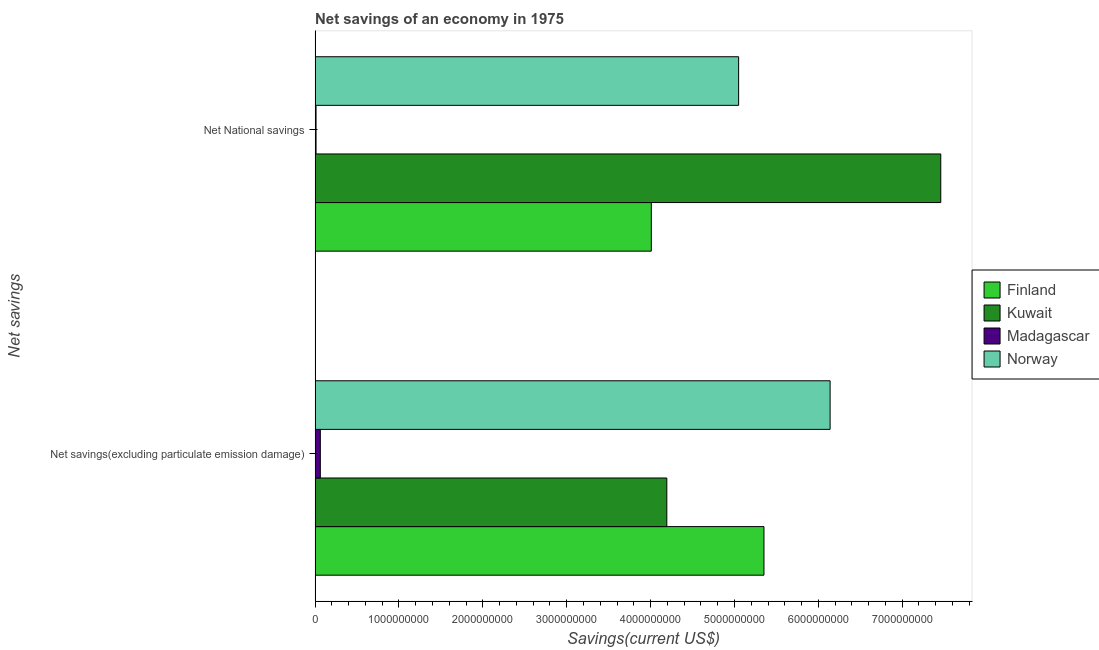How many different coloured bars are there?
Give a very brief answer. 4. Are the number of bars on each tick of the Y-axis equal?
Offer a very short reply. Yes. How many bars are there on the 2nd tick from the bottom?
Give a very brief answer. 4. What is the label of the 2nd group of bars from the top?
Provide a succinct answer. Net savings(excluding particulate emission damage). What is the net savings(excluding particulate emission damage) in Kuwait?
Ensure brevity in your answer.  4.19e+09. Across all countries, what is the maximum net savings(excluding particulate emission damage)?
Provide a short and direct response. 6.14e+09. Across all countries, what is the minimum net savings(excluding particulate emission damage)?
Make the answer very short. 6.24e+07. In which country was the net national savings maximum?
Offer a terse response. Kuwait. In which country was the net savings(excluding particulate emission damage) minimum?
Your answer should be very brief. Madagascar. What is the total net savings(excluding particulate emission damage) in the graph?
Give a very brief answer. 1.57e+1. What is the difference between the net savings(excluding particulate emission damage) in Norway and that in Finland?
Provide a succinct answer. 7.89e+08. What is the difference between the net savings(excluding particulate emission damage) in Kuwait and the net national savings in Madagascar?
Offer a very short reply. 4.18e+09. What is the average net savings(excluding particulate emission damage) per country?
Offer a very short reply. 3.94e+09. What is the difference between the net national savings and net savings(excluding particulate emission damage) in Madagascar?
Offer a terse response. -5.12e+07. What is the ratio of the net national savings in Finland to that in Madagascar?
Your answer should be very brief. 357.63. In how many countries, is the net savings(excluding particulate emission damage) greater than the average net savings(excluding particulate emission damage) taken over all countries?
Ensure brevity in your answer.  3. What does the 4th bar from the bottom in Net savings(excluding particulate emission damage) represents?
Your answer should be compact. Norway. Are all the bars in the graph horizontal?
Your answer should be compact. Yes. How many countries are there in the graph?
Give a very brief answer. 4. Are the values on the major ticks of X-axis written in scientific E-notation?
Your answer should be very brief. No. Does the graph contain any zero values?
Provide a succinct answer. No. Does the graph contain grids?
Keep it short and to the point. No. How many legend labels are there?
Your response must be concise. 4. What is the title of the graph?
Ensure brevity in your answer.  Net savings of an economy in 1975. What is the label or title of the X-axis?
Give a very brief answer. Savings(current US$). What is the label or title of the Y-axis?
Provide a short and direct response. Net savings. What is the Savings(current US$) in Finland in Net savings(excluding particulate emission damage)?
Your response must be concise. 5.35e+09. What is the Savings(current US$) in Kuwait in Net savings(excluding particulate emission damage)?
Keep it short and to the point. 4.19e+09. What is the Savings(current US$) of Madagascar in Net savings(excluding particulate emission damage)?
Your answer should be very brief. 6.24e+07. What is the Savings(current US$) in Norway in Net savings(excluding particulate emission damage)?
Keep it short and to the point. 6.14e+09. What is the Savings(current US$) of Finland in Net National savings?
Make the answer very short. 4.01e+09. What is the Savings(current US$) in Kuwait in Net National savings?
Provide a succinct answer. 7.46e+09. What is the Savings(current US$) of Madagascar in Net National savings?
Ensure brevity in your answer.  1.12e+07. What is the Savings(current US$) in Norway in Net National savings?
Keep it short and to the point. 5.05e+09. Across all Net savings, what is the maximum Savings(current US$) in Finland?
Keep it short and to the point. 5.35e+09. Across all Net savings, what is the maximum Savings(current US$) of Kuwait?
Provide a succinct answer. 7.46e+09. Across all Net savings, what is the maximum Savings(current US$) in Madagascar?
Provide a short and direct response. 6.24e+07. Across all Net savings, what is the maximum Savings(current US$) of Norway?
Give a very brief answer. 6.14e+09. Across all Net savings, what is the minimum Savings(current US$) of Finland?
Your response must be concise. 4.01e+09. Across all Net savings, what is the minimum Savings(current US$) in Kuwait?
Provide a succinct answer. 4.19e+09. Across all Net savings, what is the minimum Savings(current US$) in Madagascar?
Keep it short and to the point. 1.12e+07. Across all Net savings, what is the minimum Savings(current US$) of Norway?
Give a very brief answer. 5.05e+09. What is the total Savings(current US$) of Finland in the graph?
Ensure brevity in your answer.  9.36e+09. What is the total Savings(current US$) of Kuwait in the graph?
Your answer should be compact. 1.17e+1. What is the total Savings(current US$) in Madagascar in the graph?
Your answer should be compact. 7.36e+07. What is the total Savings(current US$) of Norway in the graph?
Offer a very short reply. 1.12e+1. What is the difference between the Savings(current US$) of Finland in Net savings(excluding particulate emission damage) and that in Net National savings?
Offer a terse response. 1.34e+09. What is the difference between the Savings(current US$) of Kuwait in Net savings(excluding particulate emission damage) and that in Net National savings?
Provide a succinct answer. -3.27e+09. What is the difference between the Savings(current US$) in Madagascar in Net savings(excluding particulate emission damage) and that in Net National savings?
Give a very brief answer. 5.12e+07. What is the difference between the Savings(current US$) of Norway in Net savings(excluding particulate emission damage) and that in Net National savings?
Offer a terse response. 1.09e+09. What is the difference between the Savings(current US$) in Finland in Net savings(excluding particulate emission damage) and the Savings(current US$) in Kuwait in Net National savings?
Give a very brief answer. -2.11e+09. What is the difference between the Savings(current US$) in Finland in Net savings(excluding particulate emission damage) and the Savings(current US$) in Madagascar in Net National savings?
Offer a very short reply. 5.34e+09. What is the difference between the Savings(current US$) in Finland in Net savings(excluding particulate emission damage) and the Savings(current US$) in Norway in Net National savings?
Keep it short and to the point. 3.02e+08. What is the difference between the Savings(current US$) in Kuwait in Net savings(excluding particulate emission damage) and the Savings(current US$) in Madagascar in Net National savings?
Ensure brevity in your answer.  4.18e+09. What is the difference between the Savings(current US$) of Kuwait in Net savings(excluding particulate emission damage) and the Savings(current US$) of Norway in Net National savings?
Provide a short and direct response. -8.56e+08. What is the difference between the Savings(current US$) in Madagascar in Net savings(excluding particulate emission damage) and the Savings(current US$) in Norway in Net National savings?
Keep it short and to the point. -4.99e+09. What is the average Savings(current US$) in Finland per Net savings?
Provide a succinct answer. 4.68e+09. What is the average Savings(current US$) of Kuwait per Net savings?
Provide a short and direct response. 5.83e+09. What is the average Savings(current US$) of Madagascar per Net savings?
Ensure brevity in your answer.  3.68e+07. What is the average Savings(current US$) of Norway per Net savings?
Make the answer very short. 5.60e+09. What is the difference between the Savings(current US$) in Finland and Savings(current US$) in Kuwait in Net savings(excluding particulate emission damage)?
Provide a short and direct response. 1.16e+09. What is the difference between the Savings(current US$) in Finland and Savings(current US$) in Madagascar in Net savings(excluding particulate emission damage)?
Offer a terse response. 5.29e+09. What is the difference between the Savings(current US$) of Finland and Savings(current US$) of Norway in Net savings(excluding particulate emission damage)?
Make the answer very short. -7.89e+08. What is the difference between the Savings(current US$) of Kuwait and Savings(current US$) of Madagascar in Net savings(excluding particulate emission damage)?
Ensure brevity in your answer.  4.13e+09. What is the difference between the Savings(current US$) in Kuwait and Savings(current US$) in Norway in Net savings(excluding particulate emission damage)?
Your response must be concise. -1.95e+09. What is the difference between the Savings(current US$) of Madagascar and Savings(current US$) of Norway in Net savings(excluding particulate emission damage)?
Offer a very short reply. -6.08e+09. What is the difference between the Savings(current US$) of Finland and Savings(current US$) of Kuwait in Net National savings?
Your response must be concise. -3.45e+09. What is the difference between the Savings(current US$) in Finland and Savings(current US$) in Madagascar in Net National savings?
Give a very brief answer. 4.00e+09. What is the difference between the Savings(current US$) of Finland and Savings(current US$) of Norway in Net National savings?
Your answer should be very brief. -1.04e+09. What is the difference between the Savings(current US$) of Kuwait and Savings(current US$) of Madagascar in Net National savings?
Give a very brief answer. 7.45e+09. What is the difference between the Savings(current US$) of Kuwait and Savings(current US$) of Norway in Net National savings?
Your answer should be compact. 2.41e+09. What is the difference between the Savings(current US$) in Madagascar and Savings(current US$) in Norway in Net National savings?
Offer a very short reply. -5.04e+09. What is the ratio of the Savings(current US$) of Finland in Net savings(excluding particulate emission damage) to that in Net National savings?
Your answer should be compact. 1.34. What is the ratio of the Savings(current US$) in Kuwait in Net savings(excluding particulate emission damage) to that in Net National savings?
Provide a succinct answer. 0.56. What is the ratio of the Savings(current US$) of Madagascar in Net savings(excluding particulate emission damage) to that in Net National savings?
Offer a terse response. 5.57. What is the ratio of the Savings(current US$) of Norway in Net savings(excluding particulate emission damage) to that in Net National savings?
Your answer should be compact. 1.22. What is the difference between the highest and the second highest Savings(current US$) in Finland?
Ensure brevity in your answer.  1.34e+09. What is the difference between the highest and the second highest Savings(current US$) in Kuwait?
Your answer should be compact. 3.27e+09. What is the difference between the highest and the second highest Savings(current US$) of Madagascar?
Keep it short and to the point. 5.12e+07. What is the difference between the highest and the second highest Savings(current US$) of Norway?
Keep it short and to the point. 1.09e+09. What is the difference between the highest and the lowest Savings(current US$) in Finland?
Provide a short and direct response. 1.34e+09. What is the difference between the highest and the lowest Savings(current US$) of Kuwait?
Give a very brief answer. 3.27e+09. What is the difference between the highest and the lowest Savings(current US$) of Madagascar?
Offer a terse response. 5.12e+07. What is the difference between the highest and the lowest Savings(current US$) of Norway?
Ensure brevity in your answer.  1.09e+09. 